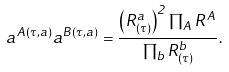Convert formula to latex. <formula><loc_0><loc_0><loc_500><loc_500>a ^ { A ( \tau , a ) } a ^ { B ( \tau , a ) } = \frac { \left ( R ^ { a } _ { ( \tau ) } \right ) ^ { 2 } \prod _ { A } R ^ { A } } { \prod _ { b } R ^ { b } _ { ( \tau ) } } .</formula> 